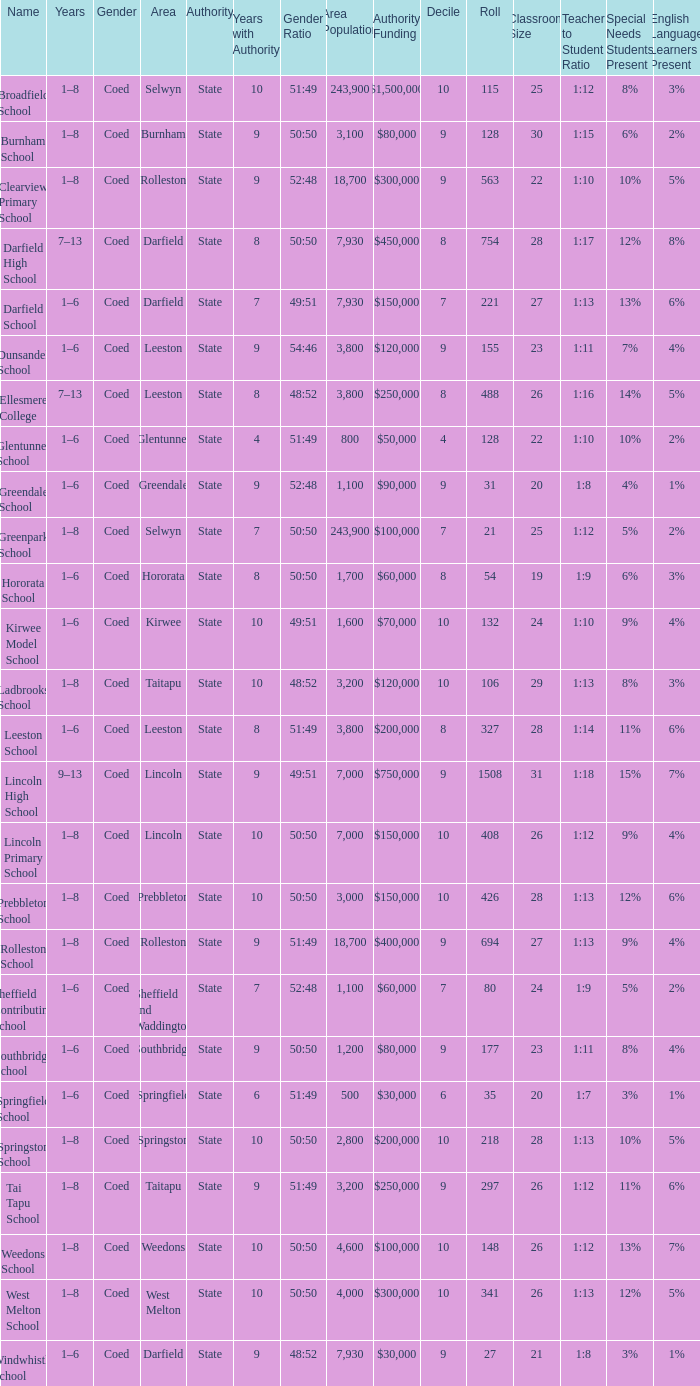How many deciles have Years of 9–13? 1.0. 